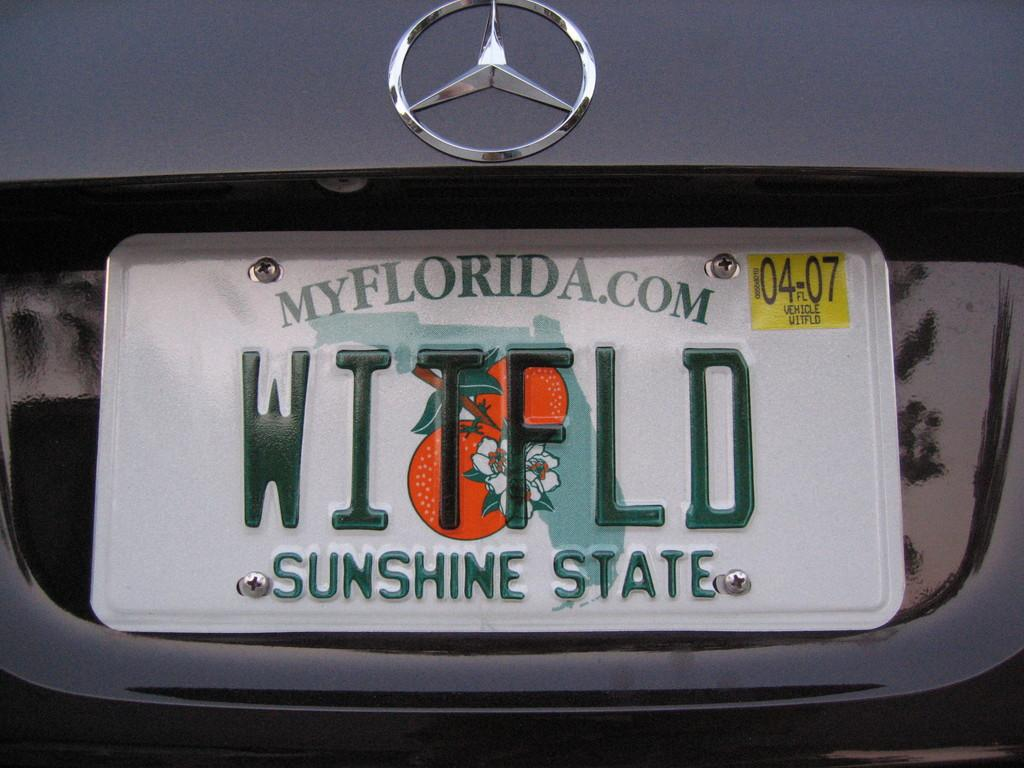<image>
Present a compact description of the photo's key features. A Florida license plate says that Florida is the sunshine state. 